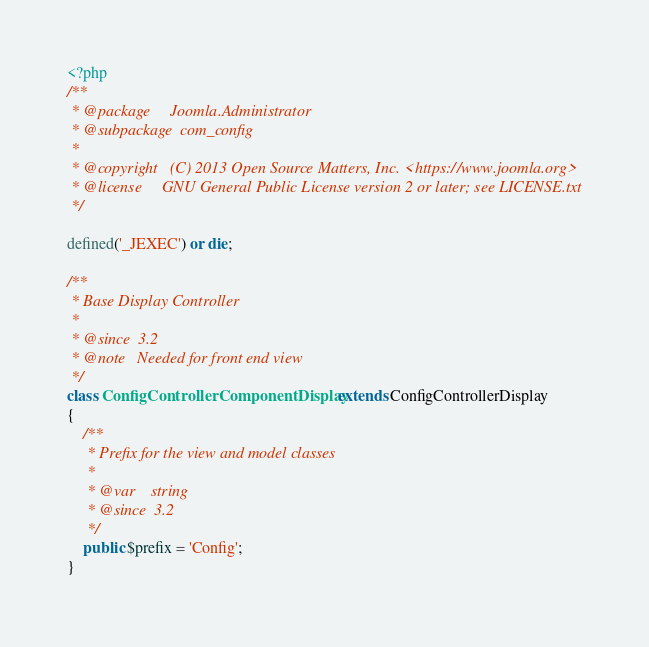Convert code to text. <code><loc_0><loc_0><loc_500><loc_500><_PHP_><?php
/**
 * @package     Joomla.Administrator
 * @subpackage  com_config
 *
 * @copyright   (C) 2013 Open Source Matters, Inc. <https://www.joomla.org>
 * @license     GNU General Public License version 2 or later; see LICENSE.txt
 */

defined('_JEXEC') or die;

/**
 * Base Display Controller
 *
 * @since  3.2
 * @note   Needed for front end view
 */
class ConfigControllerComponentDisplay extends ConfigControllerDisplay
{
	/**
	 * Prefix for the view and model classes
	 *
	 * @var    string
	 * @since  3.2
	 */
	public $prefix = 'Config';
}
</code> 